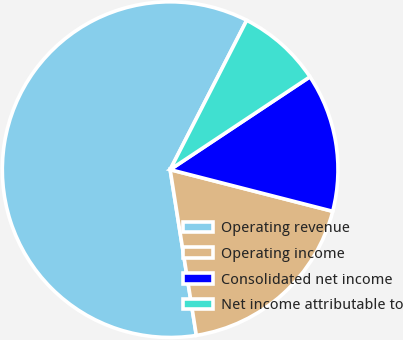<chart> <loc_0><loc_0><loc_500><loc_500><pie_chart><fcel>Operating revenue<fcel>Operating income<fcel>Consolidated net income<fcel>Net income attributable to<nl><fcel>60.03%<fcel>18.51%<fcel>13.32%<fcel>8.13%<nl></chart> 